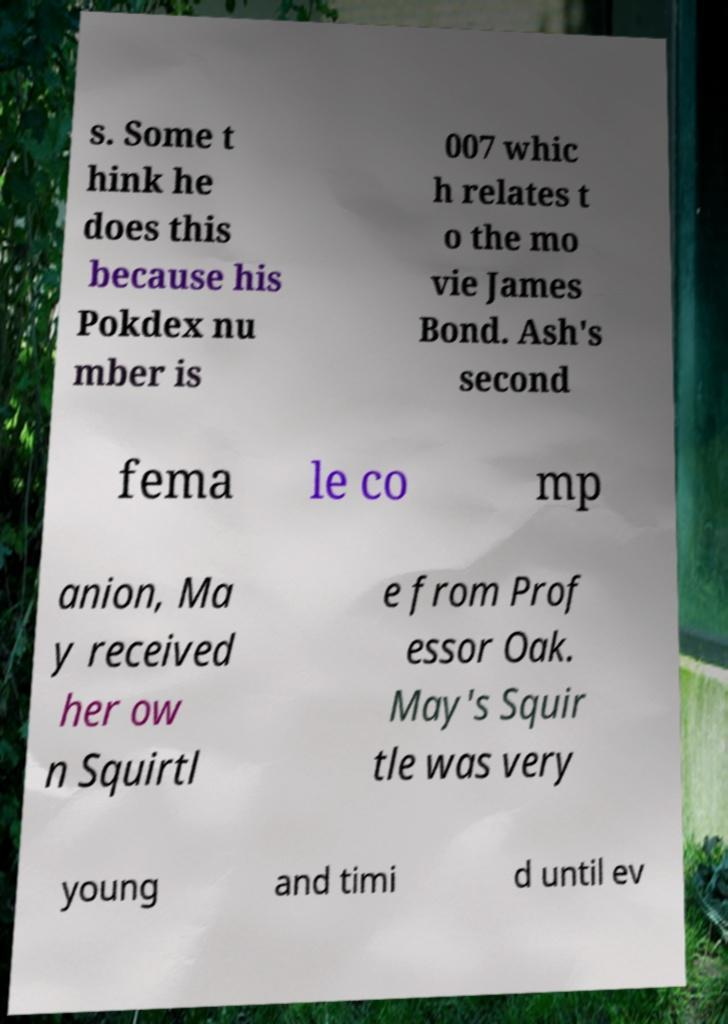Please read and relay the text visible in this image. What does it say? s. Some t hink he does this because his Pokdex nu mber is 007 whic h relates t o the mo vie James Bond. Ash's second fema le co mp anion, Ma y received her ow n Squirtl e from Prof essor Oak. May's Squir tle was very young and timi d until ev 